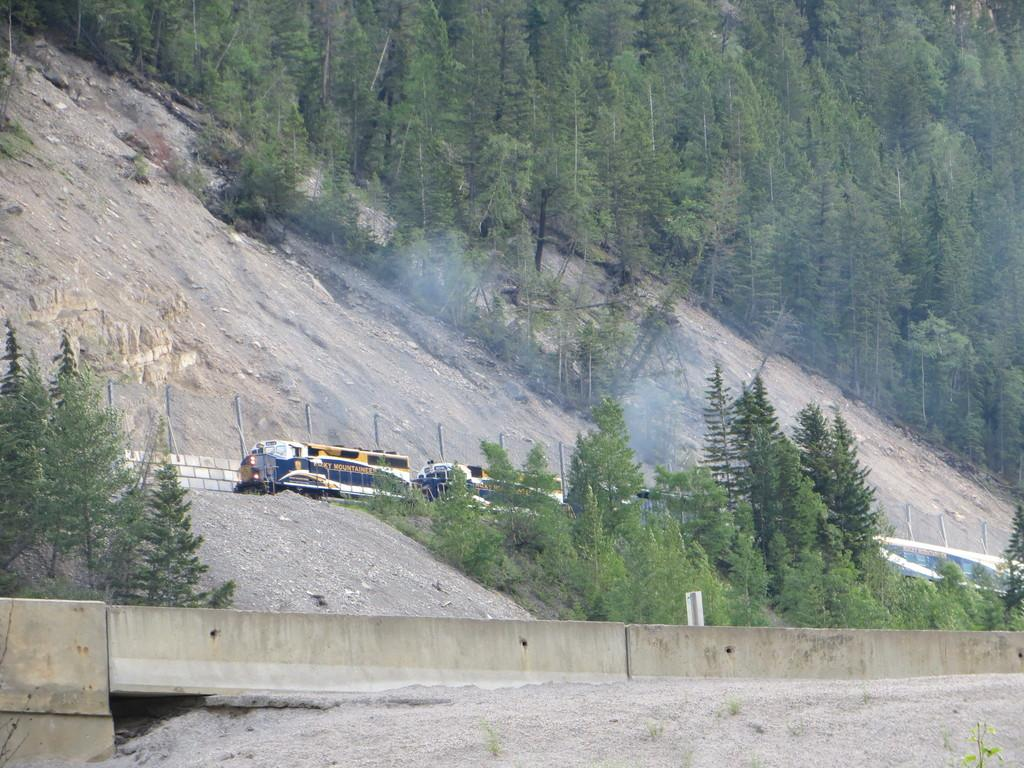What type of natural elements can be seen in the image? There are trees and hills visible in the image. What man-made structures are present in the image? There are walls and poles in the image. What type of sign or notice might be on the board in the image? It is not clear what the board is for, but it could be a sign or notice. Is there any indication of transportation in the image? It appears that there might be a train in the image. Can you hear the dinosaurs roaring in the image? There are no dinosaurs present in the image, so it is not possible to hear them roaring. 